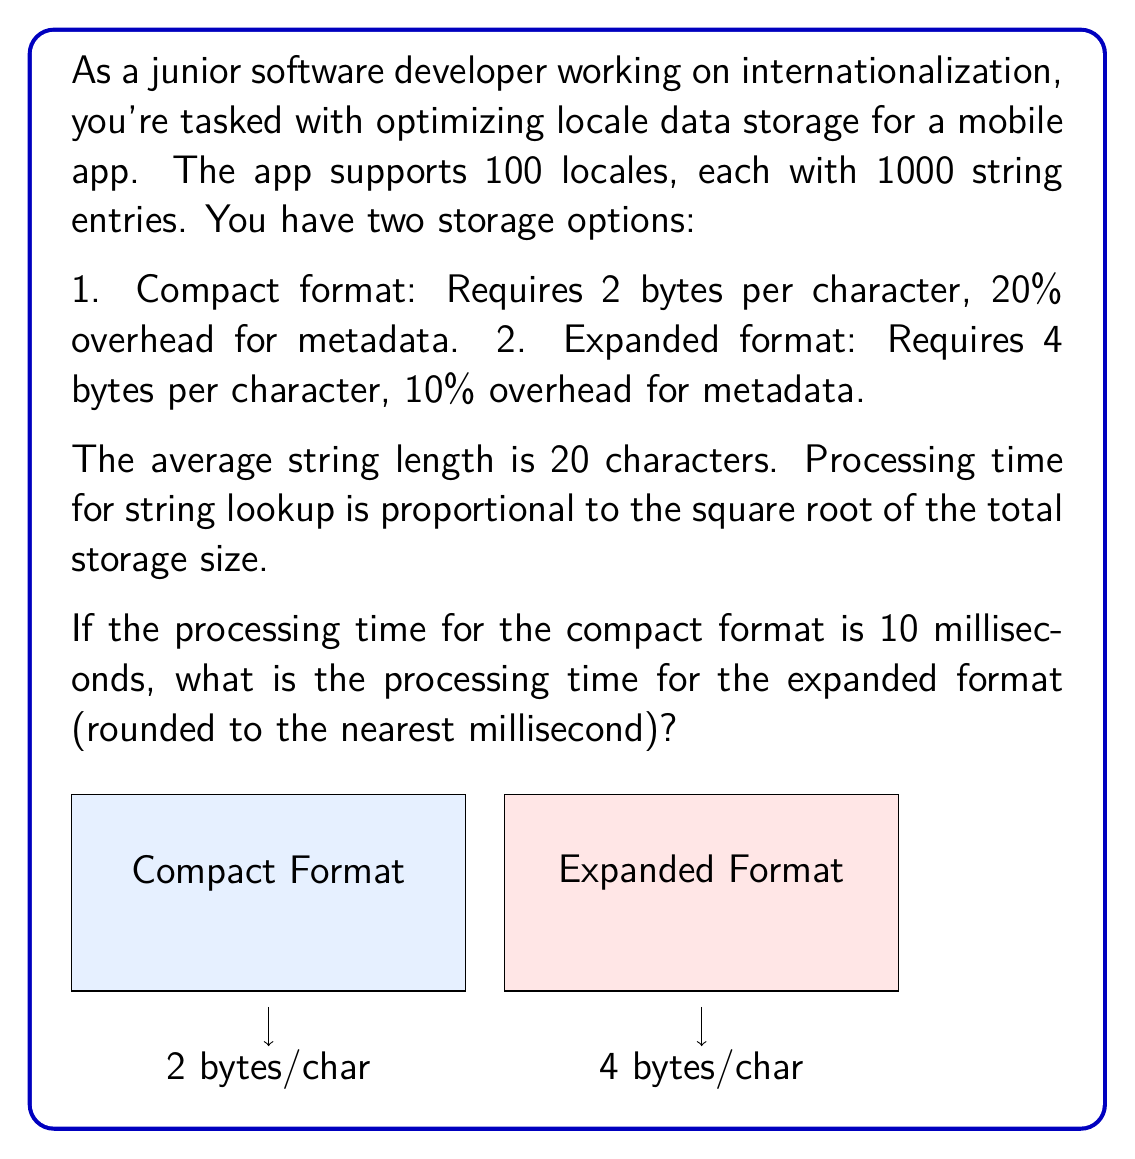Could you help me with this problem? Let's approach this step-by-step:

1) First, calculate the total storage size for each format:

   Compact format:
   - Characters: 100 locales * 1000 strings * 20 chars/string * 2 bytes/char = 4,000,000 bytes
   - With 20% overhead: 4,000,000 * 1.2 = 4,800,000 bytes

   Expanded format:
   - Characters: 100 locales * 1000 strings * 20 chars/string * 4 bytes/char = 8,000,000 bytes
   - With 10% overhead: 8,000,000 * 1.1 = 8,800,000 bytes

2) The processing time is proportional to the square root of the storage size. Let's call the proportionality constant $k$. For the compact format:

   $$10 = k \sqrt{4,800,000}$$

3) Solve for $k$:

   $$k = \frac{10}{\sqrt{4,800,000}} = \frac{10}{2191.36} = 0.00456$$

4) Now use this $k$ to calculate the processing time for the expanded format:

   $$\text{Time} = 0.00456 * \sqrt{8,800,000} = 0.00456 * 2966.48 = 13.53 \text{ ms}$$

5) Rounding to the nearest millisecond:

   $$13.53 \text{ ms} \approx 14 \text{ ms}$$
Answer: 14 ms 